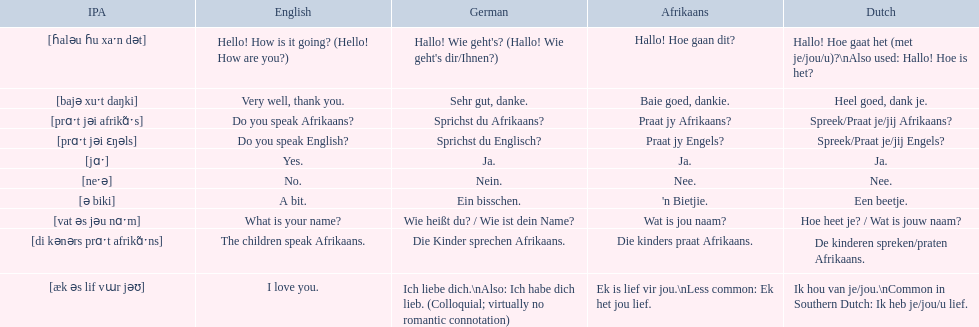How would you say the phrase the children speak afrikaans in afrikaans? Die kinders praat Afrikaans. How would you say the previous phrase in german? Die Kinder sprechen Afrikaans. 